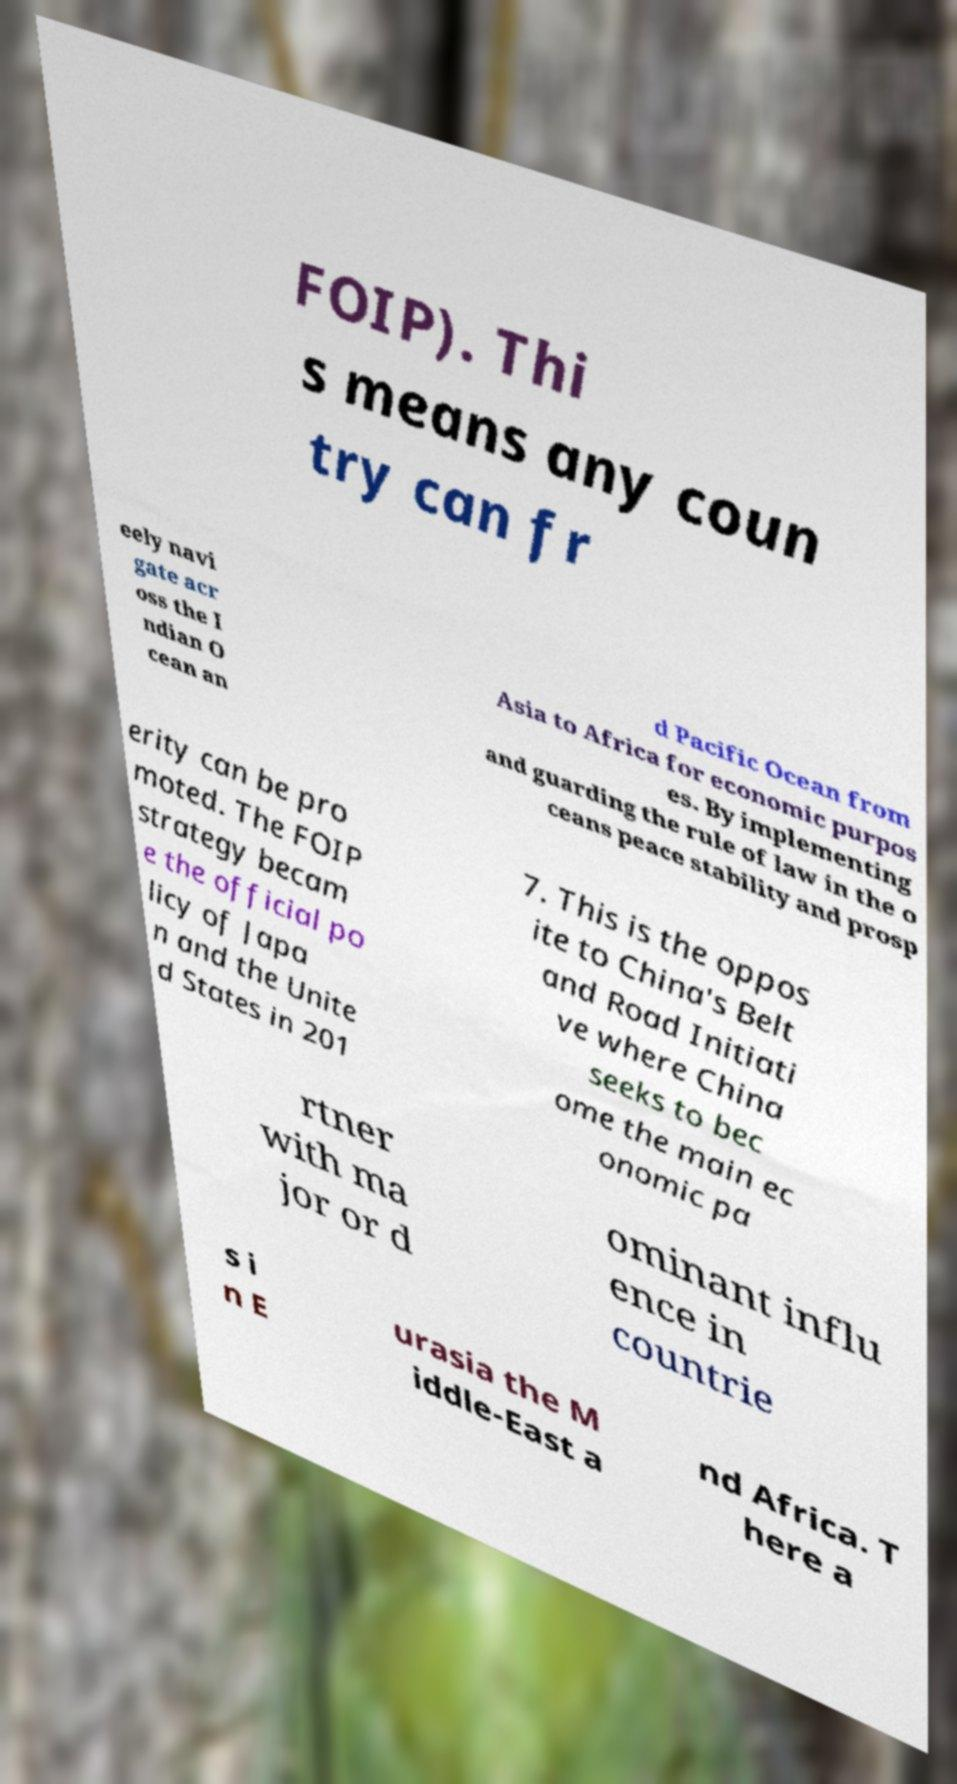Could you extract and type out the text from this image? FOIP). Thi s means any coun try can fr eely navi gate acr oss the I ndian O cean an d Pacific Ocean from Asia to Africa for economic purpos es. By implementing and guarding the rule of law in the o ceans peace stability and prosp erity can be pro moted. The FOIP strategy becam e the official po licy of Japa n and the Unite d States in 201 7. This is the oppos ite to China's Belt and Road Initiati ve where China seeks to bec ome the main ec onomic pa rtner with ma jor or d ominant influ ence in countrie s i n E urasia the M iddle-East a nd Africa. T here a 